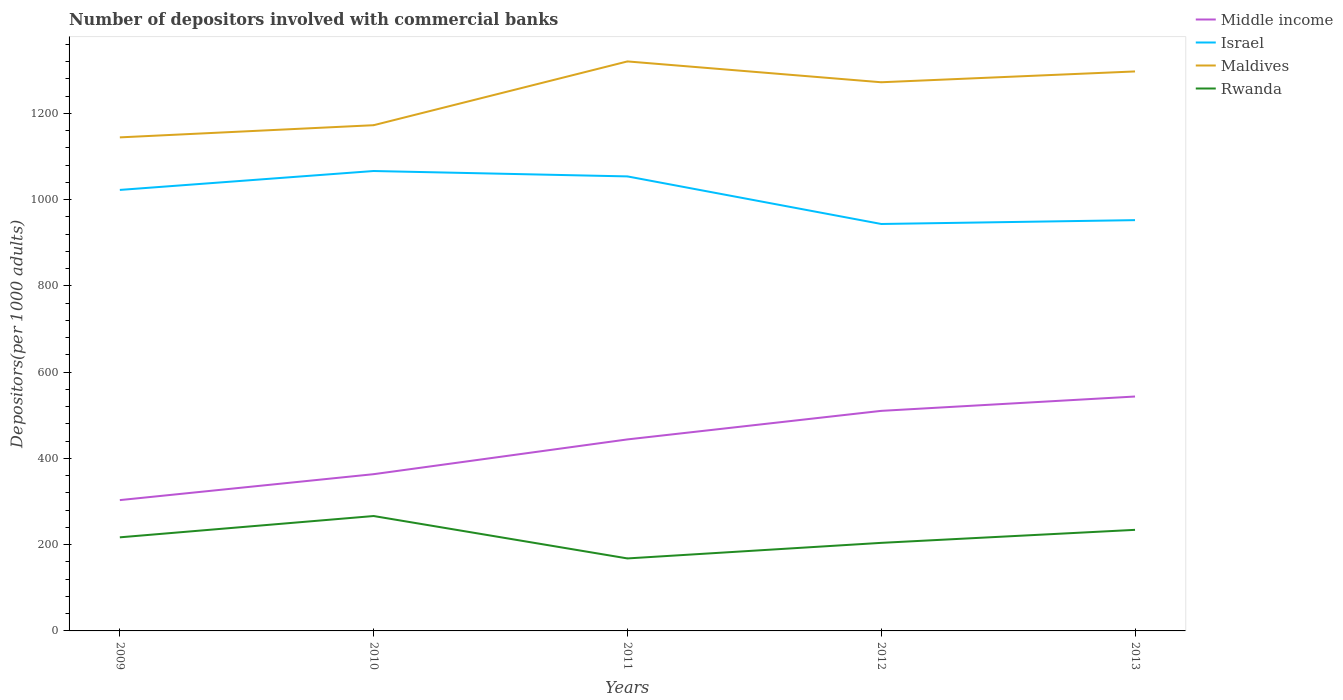How many different coloured lines are there?
Give a very brief answer. 4. Across all years, what is the maximum number of depositors involved with commercial banks in Maldives?
Your answer should be compact. 1144.57. What is the total number of depositors involved with commercial banks in Middle income in the graph?
Provide a succinct answer. -206.95. What is the difference between the highest and the second highest number of depositors involved with commercial banks in Middle income?
Your answer should be compact. 240.21. How many lines are there?
Your answer should be very brief. 4. What is the difference between two consecutive major ticks on the Y-axis?
Offer a terse response. 200. Are the values on the major ticks of Y-axis written in scientific E-notation?
Provide a short and direct response. No. Does the graph contain any zero values?
Offer a terse response. No. Where does the legend appear in the graph?
Keep it short and to the point. Top right. How many legend labels are there?
Provide a succinct answer. 4. What is the title of the graph?
Your response must be concise. Number of depositors involved with commercial banks. Does "Trinidad and Tobago" appear as one of the legend labels in the graph?
Offer a terse response. No. What is the label or title of the Y-axis?
Your answer should be very brief. Depositors(per 1000 adults). What is the Depositors(per 1000 adults) of Middle income in 2009?
Your response must be concise. 303.38. What is the Depositors(per 1000 adults) in Israel in 2009?
Give a very brief answer. 1022.7. What is the Depositors(per 1000 adults) of Maldives in 2009?
Offer a very short reply. 1144.57. What is the Depositors(per 1000 adults) in Rwanda in 2009?
Provide a succinct answer. 217.05. What is the Depositors(per 1000 adults) of Middle income in 2010?
Provide a short and direct response. 363.5. What is the Depositors(per 1000 adults) of Israel in 2010?
Keep it short and to the point. 1066.56. What is the Depositors(per 1000 adults) of Maldives in 2010?
Make the answer very short. 1172.79. What is the Depositors(per 1000 adults) of Rwanda in 2010?
Offer a terse response. 266.46. What is the Depositors(per 1000 adults) of Middle income in 2011?
Ensure brevity in your answer.  444.11. What is the Depositors(per 1000 adults) in Israel in 2011?
Offer a very short reply. 1054.06. What is the Depositors(per 1000 adults) in Maldives in 2011?
Provide a succinct answer. 1320.69. What is the Depositors(per 1000 adults) of Rwanda in 2011?
Provide a succinct answer. 168.11. What is the Depositors(per 1000 adults) of Middle income in 2012?
Provide a short and direct response. 510.34. What is the Depositors(per 1000 adults) in Israel in 2012?
Keep it short and to the point. 943.72. What is the Depositors(per 1000 adults) of Maldives in 2012?
Ensure brevity in your answer.  1272.39. What is the Depositors(per 1000 adults) of Rwanda in 2012?
Your response must be concise. 204.22. What is the Depositors(per 1000 adults) of Middle income in 2013?
Your answer should be compact. 543.59. What is the Depositors(per 1000 adults) in Israel in 2013?
Your response must be concise. 952.62. What is the Depositors(per 1000 adults) in Maldives in 2013?
Provide a succinct answer. 1297.48. What is the Depositors(per 1000 adults) in Rwanda in 2013?
Your answer should be compact. 234.42. Across all years, what is the maximum Depositors(per 1000 adults) of Middle income?
Your response must be concise. 543.59. Across all years, what is the maximum Depositors(per 1000 adults) of Israel?
Keep it short and to the point. 1066.56. Across all years, what is the maximum Depositors(per 1000 adults) in Maldives?
Your answer should be compact. 1320.69. Across all years, what is the maximum Depositors(per 1000 adults) of Rwanda?
Offer a terse response. 266.46. Across all years, what is the minimum Depositors(per 1000 adults) in Middle income?
Your answer should be compact. 303.38. Across all years, what is the minimum Depositors(per 1000 adults) in Israel?
Keep it short and to the point. 943.72. Across all years, what is the minimum Depositors(per 1000 adults) in Maldives?
Keep it short and to the point. 1144.57. Across all years, what is the minimum Depositors(per 1000 adults) in Rwanda?
Keep it short and to the point. 168.11. What is the total Depositors(per 1000 adults) of Middle income in the graph?
Offer a terse response. 2164.92. What is the total Depositors(per 1000 adults) in Israel in the graph?
Provide a short and direct response. 5039.66. What is the total Depositors(per 1000 adults) in Maldives in the graph?
Your answer should be compact. 6207.91. What is the total Depositors(per 1000 adults) of Rwanda in the graph?
Give a very brief answer. 1090.24. What is the difference between the Depositors(per 1000 adults) of Middle income in 2009 and that in 2010?
Your answer should be very brief. -60.11. What is the difference between the Depositors(per 1000 adults) of Israel in 2009 and that in 2010?
Your answer should be compact. -43.86. What is the difference between the Depositors(per 1000 adults) of Maldives in 2009 and that in 2010?
Make the answer very short. -28.22. What is the difference between the Depositors(per 1000 adults) of Rwanda in 2009 and that in 2010?
Your response must be concise. -49.41. What is the difference between the Depositors(per 1000 adults) in Middle income in 2009 and that in 2011?
Your response must be concise. -140.73. What is the difference between the Depositors(per 1000 adults) of Israel in 2009 and that in 2011?
Your answer should be very brief. -31.36. What is the difference between the Depositors(per 1000 adults) in Maldives in 2009 and that in 2011?
Offer a terse response. -176.13. What is the difference between the Depositors(per 1000 adults) of Rwanda in 2009 and that in 2011?
Ensure brevity in your answer.  48.94. What is the difference between the Depositors(per 1000 adults) of Middle income in 2009 and that in 2012?
Provide a short and direct response. -206.95. What is the difference between the Depositors(per 1000 adults) of Israel in 2009 and that in 2012?
Your response must be concise. 78.98. What is the difference between the Depositors(per 1000 adults) of Maldives in 2009 and that in 2012?
Make the answer very short. -127.82. What is the difference between the Depositors(per 1000 adults) of Rwanda in 2009 and that in 2012?
Provide a short and direct response. 12.83. What is the difference between the Depositors(per 1000 adults) of Middle income in 2009 and that in 2013?
Your answer should be compact. -240.21. What is the difference between the Depositors(per 1000 adults) of Israel in 2009 and that in 2013?
Your response must be concise. 70.08. What is the difference between the Depositors(per 1000 adults) in Maldives in 2009 and that in 2013?
Ensure brevity in your answer.  -152.92. What is the difference between the Depositors(per 1000 adults) of Rwanda in 2009 and that in 2013?
Make the answer very short. -17.37. What is the difference between the Depositors(per 1000 adults) of Middle income in 2010 and that in 2011?
Give a very brief answer. -80.61. What is the difference between the Depositors(per 1000 adults) in Israel in 2010 and that in 2011?
Your response must be concise. 12.5. What is the difference between the Depositors(per 1000 adults) of Maldives in 2010 and that in 2011?
Offer a very short reply. -147.91. What is the difference between the Depositors(per 1000 adults) of Rwanda in 2010 and that in 2011?
Make the answer very short. 98.35. What is the difference between the Depositors(per 1000 adults) in Middle income in 2010 and that in 2012?
Make the answer very short. -146.84. What is the difference between the Depositors(per 1000 adults) in Israel in 2010 and that in 2012?
Keep it short and to the point. 122.84. What is the difference between the Depositors(per 1000 adults) of Maldives in 2010 and that in 2012?
Make the answer very short. -99.6. What is the difference between the Depositors(per 1000 adults) of Rwanda in 2010 and that in 2012?
Give a very brief answer. 62.24. What is the difference between the Depositors(per 1000 adults) of Middle income in 2010 and that in 2013?
Ensure brevity in your answer.  -180.09. What is the difference between the Depositors(per 1000 adults) in Israel in 2010 and that in 2013?
Offer a terse response. 113.94. What is the difference between the Depositors(per 1000 adults) of Maldives in 2010 and that in 2013?
Your answer should be compact. -124.7. What is the difference between the Depositors(per 1000 adults) in Rwanda in 2010 and that in 2013?
Your answer should be compact. 32.04. What is the difference between the Depositors(per 1000 adults) of Middle income in 2011 and that in 2012?
Your answer should be compact. -66.23. What is the difference between the Depositors(per 1000 adults) of Israel in 2011 and that in 2012?
Offer a very short reply. 110.33. What is the difference between the Depositors(per 1000 adults) of Maldives in 2011 and that in 2012?
Ensure brevity in your answer.  48.3. What is the difference between the Depositors(per 1000 adults) in Rwanda in 2011 and that in 2012?
Ensure brevity in your answer.  -36.1. What is the difference between the Depositors(per 1000 adults) in Middle income in 2011 and that in 2013?
Offer a very short reply. -99.48. What is the difference between the Depositors(per 1000 adults) in Israel in 2011 and that in 2013?
Your answer should be compact. 101.44. What is the difference between the Depositors(per 1000 adults) in Maldives in 2011 and that in 2013?
Ensure brevity in your answer.  23.21. What is the difference between the Depositors(per 1000 adults) of Rwanda in 2011 and that in 2013?
Provide a succinct answer. -66.31. What is the difference between the Depositors(per 1000 adults) of Middle income in 2012 and that in 2013?
Keep it short and to the point. -33.25. What is the difference between the Depositors(per 1000 adults) in Israel in 2012 and that in 2013?
Offer a terse response. -8.9. What is the difference between the Depositors(per 1000 adults) of Maldives in 2012 and that in 2013?
Offer a terse response. -25.1. What is the difference between the Depositors(per 1000 adults) of Rwanda in 2012 and that in 2013?
Give a very brief answer. -30.2. What is the difference between the Depositors(per 1000 adults) in Middle income in 2009 and the Depositors(per 1000 adults) in Israel in 2010?
Offer a very short reply. -763.18. What is the difference between the Depositors(per 1000 adults) in Middle income in 2009 and the Depositors(per 1000 adults) in Maldives in 2010?
Your response must be concise. -869.4. What is the difference between the Depositors(per 1000 adults) in Middle income in 2009 and the Depositors(per 1000 adults) in Rwanda in 2010?
Give a very brief answer. 36.93. What is the difference between the Depositors(per 1000 adults) in Israel in 2009 and the Depositors(per 1000 adults) in Maldives in 2010?
Your response must be concise. -150.09. What is the difference between the Depositors(per 1000 adults) in Israel in 2009 and the Depositors(per 1000 adults) in Rwanda in 2010?
Keep it short and to the point. 756.24. What is the difference between the Depositors(per 1000 adults) in Maldives in 2009 and the Depositors(per 1000 adults) in Rwanda in 2010?
Keep it short and to the point. 878.11. What is the difference between the Depositors(per 1000 adults) of Middle income in 2009 and the Depositors(per 1000 adults) of Israel in 2011?
Give a very brief answer. -750.67. What is the difference between the Depositors(per 1000 adults) in Middle income in 2009 and the Depositors(per 1000 adults) in Maldives in 2011?
Your response must be concise. -1017.31. What is the difference between the Depositors(per 1000 adults) in Middle income in 2009 and the Depositors(per 1000 adults) in Rwanda in 2011?
Your response must be concise. 135.27. What is the difference between the Depositors(per 1000 adults) in Israel in 2009 and the Depositors(per 1000 adults) in Maldives in 2011?
Make the answer very short. -297.99. What is the difference between the Depositors(per 1000 adults) in Israel in 2009 and the Depositors(per 1000 adults) in Rwanda in 2011?
Make the answer very short. 854.59. What is the difference between the Depositors(per 1000 adults) in Maldives in 2009 and the Depositors(per 1000 adults) in Rwanda in 2011?
Your answer should be compact. 976.45. What is the difference between the Depositors(per 1000 adults) of Middle income in 2009 and the Depositors(per 1000 adults) of Israel in 2012?
Make the answer very short. -640.34. What is the difference between the Depositors(per 1000 adults) in Middle income in 2009 and the Depositors(per 1000 adults) in Maldives in 2012?
Offer a very short reply. -969. What is the difference between the Depositors(per 1000 adults) of Middle income in 2009 and the Depositors(per 1000 adults) of Rwanda in 2012?
Your response must be concise. 99.17. What is the difference between the Depositors(per 1000 adults) of Israel in 2009 and the Depositors(per 1000 adults) of Maldives in 2012?
Offer a terse response. -249.69. What is the difference between the Depositors(per 1000 adults) of Israel in 2009 and the Depositors(per 1000 adults) of Rwanda in 2012?
Give a very brief answer. 818.48. What is the difference between the Depositors(per 1000 adults) in Maldives in 2009 and the Depositors(per 1000 adults) in Rwanda in 2012?
Your answer should be very brief. 940.35. What is the difference between the Depositors(per 1000 adults) of Middle income in 2009 and the Depositors(per 1000 adults) of Israel in 2013?
Offer a very short reply. -649.24. What is the difference between the Depositors(per 1000 adults) in Middle income in 2009 and the Depositors(per 1000 adults) in Maldives in 2013?
Ensure brevity in your answer.  -994.1. What is the difference between the Depositors(per 1000 adults) in Middle income in 2009 and the Depositors(per 1000 adults) in Rwanda in 2013?
Your answer should be compact. 68.97. What is the difference between the Depositors(per 1000 adults) of Israel in 2009 and the Depositors(per 1000 adults) of Maldives in 2013?
Your answer should be very brief. -274.78. What is the difference between the Depositors(per 1000 adults) of Israel in 2009 and the Depositors(per 1000 adults) of Rwanda in 2013?
Your answer should be compact. 788.28. What is the difference between the Depositors(per 1000 adults) of Maldives in 2009 and the Depositors(per 1000 adults) of Rwanda in 2013?
Ensure brevity in your answer.  910.15. What is the difference between the Depositors(per 1000 adults) in Middle income in 2010 and the Depositors(per 1000 adults) in Israel in 2011?
Ensure brevity in your answer.  -690.56. What is the difference between the Depositors(per 1000 adults) of Middle income in 2010 and the Depositors(per 1000 adults) of Maldives in 2011?
Offer a terse response. -957.2. What is the difference between the Depositors(per 1000 adults) of Middle income in 2010 and the Depositors(per 1000 adults) of Rwanda in 2011?
Provide a succinct answer. 195.39. What is the difference between the Depositors(per 1000 adults) in Israel in 2010 and the Depositors(per 1000 adults) in Maldives in 2011?
Your answer should be very brief. -254.13. What is the difference between the Depositors(per 1000 adults) of Israel in 2010 and the Depositors(per 1000 adults) of Rwanda in 2011?
Offer a very short reply. 898.45. What is the difference between the Depositors(per 1000 adults) of Maldives in 2010 and the Depositors(per 1000 adults) of Rwanda in 2011?
Keep it short and to the point. 1004.68. What is the difference between the Depositors(per 1000 adults) in Middle income in 2010 and the Depositors(per 1000 adults) in Israel in 2012?
Your response must be concise. -580.23. What is the difference between the Depositors(per 1000 adults) in Middle income in 2010 and the Depositors(per 1000 adults) in Maldives in 2012?
Keep it short and to the point. -908.89. What is the difference between the Depositors(per 1000 adults) of Middle income in 2010 and the Depositors(per 1000 adults) of Rwanda in 2012?
Your answer should be very brief. 159.28. What is the difference between the Depositors(per 1000 adults) of Israel in 2010 and the Depositors(per 1000 adults) of Maldives in 2012?
Make the answer very short. -205.83. What is the difference between the Depositors(per 1000 adults) of Israel in 2010 and the Depositors(per 1000 adults) of Rwanda in 2012?
Give a very brief answer. 862.35. What is the difference between the Depositors(per 1000 adults) of Maldives in 2010 and the Depositors(per 1000 adults) of Rwanda in 2012?
Your answer should be very brief. 968.57. What is the difference between the Depositors(per 1000 adults) of Middle income in 2010 and the Depositors(per 1000 adults) of Israel in 2013?
Offer a terse response. -589.12. What is the difference between the Depositors(per 1000 adults) of Middle income in 2010 and the Depositors(per 1000 adults) of Maldives in 2013?
Your answer should be compact. -933.99. What is the difference between the Depositors(per 1000 adults) in Middle income in 2010 and the Depositors(per 1000 adults) in Rwanda in 2013?
Offer a very short reply. 129.08. What is the difference between the Depositors(per 1000 adults) of Israel in 2010 and the Depositors(per 1000 adults) of Maldives in 2013?
Your answer should be compact. -230.92. What is the difference between the Depositors(per 1000 adults) in Israel in 2010 and the Depositors(per 1000 adults) in Rwanda in 2013?
Provide a short and direct response. 832.14. What is the difference between the Depositors(per 1000 adults) in Maldives in 2010 and the Depositors(per 1000 adults) in Rwanda in 2013?
Make the answer very short. 938.37. What is the difference between the Depositors(per 1000 adults) in Middle income in 2011 and the Depositors(per 1000 adults) in Israel in 2012?
Offer a terse response. -499.61. What is the difference between the Depositors(per 1000 adults) in Middle income in 2011 and the Depositors(per 1000 adults) in Maldives in 2012?
Make the answer very short. -828.28. What is the difference between the Depositors(per 1000 adults) of Middle income in 2011 and the Depositors(per 1000 adults) of Rwanda in 2012?
Give a very brief answer. 239.89. What is the difference between the Depositors(per 1000 adults) in Israel in 2011 and the Depositors(per 1000 adults) in Maldives in 2012?
Provide a succinct answer. -218.33. What is the difference between the Depositors(per 1000 adults) of Israel in 2011 and the Depositors(per 1000 adults) of Rwanda in 2012?
Give a very brief answer. 849.84. What is the difference between the Depositors(per 1000 adults) of Maldives in 2011 and the Depositors(per 1000 adults) of Rwanda in 2012?
Provide a succinct answer. 1116.48. What is the difference between the Depositors(per 1000 adults) of Middle income in 2011 and the Depositors(per 1000 adults) of Israel in 2013?
Provide a short and direct response. -508.51. What is the difference between the Depositors(per 1000 adults) of Middle income in 2011 and the Depositors(per 1000 adults) of Maldives in 2013?
Your response must be concise. -853.37. What is the difference between the Depositors(per 1000 adults) in Middle income in 2011 and the Depositors(per 1000 adults) in Rwanda in 2013?
Your answer should be compact. 209.69. What is the difference between the Depositors(per 1000 adults) in Israel in 2011 and the Depositors(per 1000 adults) in Maldives in 2013?
Provide a short and direct response. -243.43. What is the difference between the Depositors(per 1000 adults) in Israel in 2011 and the Depositors(per 1000 adults) in Rwanda in 2013?
Keep it short and to the point. 819.64. What is the difference between the Depositors(per 1000 adults) in Maldives in 2011 and the Depositors(per 1000 adults) in Rwanda in 2013?
Your answer should be very brief. 1086.28. What is the difference between the Depositors(per 1000 adults) of Middle income in 2012 and the Depositors(per 1000 adults) of Israel in 2013?
Offer a very short reply. -442.29. What is the difference between the Depositors(per 1000 adults) of Middle income in 2012 and the Depositors(per 1000 adults) of Maldives in 2013?
Offer a very short reply. -787.15. What is the difference between the Depositors(per 1000 adults) of Middle income in 2012 and the Depositors(per 1000 adults) of Rwanda in 2013?
Give a very brief answer. 275.92. What is the difference between the Depositors(per 1000 adults) in Israel in 2012 and the Depositors(per 1000 adults) in Maldives in 2013?
Your response must be concise. -353.76. What is the difference between the Depositors(per 1000 adults) in Israel in 2012 and the Depositors(per 1000 adults) in Rwanda in 2013?
Your answer should be very brief. 709.31. What is the difference between the Depositors(per 1000 adults) in Maldives in 2012 and the Depositors(per 1000 adults) in Rwanda in 2013?
Offer a very short reply. 1037.97. What is the average Depositors(per 1000 adults) of Middle income per year?
Ensure brevity in your answer.  432.98. What is the average Depositors(per 1000 adults) of Israel per year?
Give a very brief answer. 1007.93. What is the average Depositors(per 1000 adults) of Maldives per year?
Your answer should be very brief. 1241.58. What is the average Depositors(per 1000 adults) in Rwanda per year?
Offer a very short reply. 218.05. In the year 2009, what is the difference between the Depositors(per 1000 adults) in Middle income and Depositors(per 1000 adults) in Israel?
Keep it short and to the point. -719.32. In the year 2009, what is the difference between the Depositors(per 1000 adults) in Middle income and Depositors(per 1000 adults) in Maldives?
Make the answer very short. -841.18. In the year 2009, what is the difference between the Depositors(per 1000 adults) in Middle income and Depositors(per 1000 adults) in Rwanda?
Your response must be concise. 86.34. In the year 2009, what is the difference between the Depositors(per 1000 adults) in Israel and Depositors(per 1000 adults) in Maldives?
Make the answer very short. -121.86. In the year 2009, what is the difference between the Depositors(per 1000 adults) in Israel and Depositors(per 1000 adults) in Rwanda?
Provide a short and direct response. 805.65. In the year 2009, what is the difference between the Depositors(per 1000 adults) in Maldives and Depositors(per 1000 adults) in Rwanda?
Offer a terse response. 927.52. In the year 2010, what is the difference between the Depositors(per 1000 adults) in Middle income and Depositors(per 1000 adults) in Israel?
Provide a succinct answer. -703.07. In the year 2010, what is the difference between the Depositors(per 1000 adults) of Middle income and Depositors(per 1000 adults) of Maldives?
Make the answer very short. -809.29. In the year 2010, what is the difference between the Depositors(per 1000 adults) of Middle income and Depositors(per 1000 adults) of Rwanda?
Your answer should be very brief. 97.04. In the year 2010, what is the difference between the Depositors(per 1000 adults) in Israel and Depositors(per 1000 adults) in Maldives?
Your response must be concise. -106.22. In the year 2010, what is the difference between the Depositors(per 1000 adults) of Israel and Depositors(per 1000 adults) of Rwanda?
Offer a terse response. 800.1. In the year 2010, what is the difference between the Depositors(per 1000 adults) in Maldives and Depositors(per 1000 adults) in Rwanda?
Give a very brief answer. 906.33. In the year 2011, what is the difference between the Depositors(per 1000 adults) of Middle income and Depositors(per 1000 adults) of Israel?
Ensure brevity in your answer.  -609.95. In the year 2011, what is the difference between the Depositors(per 1000 adults) of Middle income and Depositors(per 1000 adults) of Maldives?
Your answer should be very brief. -876.58. In the year 2011, what is the difference between the Depositors(per 1000 adults) of Middle income and Depositors(per 1000 adults) of Rwanda?
Provide a short and direct response. 276. In the year 2011, what is the difference between the Depositors(per 1000 adults) of Israel and Depositors(per 1000 adults) of Maldives?
Provide a short and direct response. -266.63. In the year 2011, what is the difference between the Depositors(per 1000 adults) of Israel and Depositors(per 1000 adults) of Rwanda?
Your answer should be very brief. 885.95. In the year 2011, what is the difference between the Depositors(per 1000 adults) in Maldives and Depositors(per 1000 adults) in Rwanda?
Your answer should be very brief. 1152.58. In the year 2012, what is the difference between the Depositors(per 1000 adults) of Middle income and Depositors(per 1000 adults) of Israel?
Give a very brief answer. -433.39. In the year 2012, what is the difference between the Depositors(per 1000 adults) of Middle income and Depositors(per 1000 adults) of Maldives?
Provide a succinct answer. -762.05. In the year 2012, what is the difference between the Depositors(per 1000 adults) of Middle income and Depositors(per 1000 adults) of Rwanda?
Your answer should be very brief. 306.12. In the year 2012, what is the difference between the Depositors(per 1000 adults) of Israel and Depositors(per 1000 adults) of Maldives?
Provide a short and direct response. -328.66. In the year 2012, what is the difference between the Depositors(per 1000 adults) in Israel and Depositors(per 1000 adults) in Rwanda?
Provide a short and direct response. 739.51. In the year 2012, what is the difference between the Depositors(per 1000 adults) of Maldives and Depositors(per 1000 adults) of Rwanda?
Offer a very short reply. 1068.17. In the year 2013, what is the difference between the Depositors(per 1000 adults) in Middle income and Depositors(per 1000 adults) in Israel?
Offer a very short reply. -409.03. In the year 2013, what is the difference between the Depositors(per 1000 adults) in Middle income and Depositors(per 1000 adults) in Maldives?
Your answer should be compact. -753.89. In the year 2013, what is the difference between the Depositors(per 1000 adults) in Middle income and Depositors(per 1000 adults) in Rwanda?
Ensure brevity in your answer.  309.17. In the year 2013, what is the difference between the Depositors(per 1000 adults) of Israel and Depositors(per 1000 adults) of Maldives?
Your answer should be very brief. -344.86. In the year 2013, what is the difference between the Depositors(per 1000 adults) of Israel and Depositors(per 1000 adults) of Rwanda?
Your answer should be compact. 718.2. In the year 2013, what is the difference between the Depositors(per 1000 adults) of Maldives and Depositors(per 1000 adults) of Rwanda?
Give a very brief answer. 1063.07. What is the ratio of the Depositors(per 1000 adults) of Middle income in 2009 to that in 2010?
Offer a very short reply. 0.83. What is the ratio of the Depositors(per 1000 adults) of Israel in 2009 to that in 2010?
Offer a terse response. 0.96. What is the ratio of the Depositors(per 1000 adults) of Maldives in 2009 to that in 2010?
Make the answer very short. 0.98. What is the ratio of the Depositors(per 1000 adults) of Rwanda in 2009 to that in 2010?
Offer a very short reply. 0.81. What is the ratio of the Depositors(per 1000 adults) of Middle income in 2009 to that in 2011?
Make the answer very short. 0.68. What is the ratio of the Depositors(per 1000 adults) in Israel in 2009 to that in 2011?
Keep it short and to the point. 0.97. What is the ratio of the Depositors(per 1000 adults) in Maldives in 2009 to that in 2011?
Make the answer very short. 0.87. What is the ratio of the Depositors(per 1000 adults) in Rwanda in 2009 to that in 2011?
Give a very brief answer. 1.29. What is the ratio of the Depositors(per 1000 adults) of Middle income in 2009 to that in 2012?
Offer a terse response. 0.59. What is the ratio of the Depositors(per 1000 adults) of Israel in 2009 to that in 2012?
Offer a terse response. 1.08. What is the ratio of the Depositors(per 1000 adults) in Maldives in 2009 to that in 2012?
Offer a very short reply. 0.9. What is the ratio of the Depositors(per 1000 adults) in Rwanda in 2009 to that in 2012?
Make the answer very short. 1.06. What is the ratio of the Depositors(per 1000 adults) of Middle income in 2009 to that in 2013?
Provide a succinct answer. 0.56. What is the ratio of the Depositors(per 1000 adults) in Israel in 2009 to that in 2013?
Make the answer very short. 1.07. What is the ratio of the Depositors(per 1000 adults) in Maldives in 2009 to that in 2013?
Your answer should be compact. 0.88. What is the ratio of the Depositors(per 1000 adults) in Rwanda in 2009 to that in 2013?
Keep it short and to the point. 0.93. What is the ratio of the Depositors(per 1000 adults) of Middle income in 2010 to that in 2011?
Make the answer very short. 0.82. What is the ratio of the Depositors(per 1000 adults) of Israel in 2010 to that in 2011?
Make the answer very short. 1.01. What is the ratio of the Depositors(per 1000 adults) in Maldives in 2010 to that in 2011?
Provide a succinct answer. 0.89. What is the ratio of the Depositors(per 1000 adults) in Rwanda in 2010 to that in 2011?
Ensure brevity in your answer.  1.58. What is the ratio of the Depositors(per 1000 adults) of Middle income in 2010 to that in 2012?
Your response must be concise. 0.71. What is the ratio of the Depositors(per 1000 adults) of Israel in 2010 to that in 2012?
Keep it short and to the point. 1.13. What is the ratio of the Depositors(per 1000 adults) of Maldives in 2010 to that in 2012?
Your answer should be compact. 0.92. What is the ratio of the Depositors(per 1000 adults) of Rwanda in 2010 to that in 2012?
Provide a short and direct response. 1.3. What is the ratio of the Depositors(per 1000 adults) of Middle income in 2010 to that in 2013?
Give a very brief answer. 0.67. What is the ratio of the Depositors(per 1000 adults) of Israel in 2010 to that in 2013?
Keep it short and to the point. 1.12. What is the ratio of the Depositors(per 1000 adults) in Maldives in 2010 to that in 2013?
Provide a short and direct response. 0.9. What is the ratio of the Depositors(per 1000 adults) in Rwanda in 2010 to that in 2013?
Your response must be concise. 1.14. What is the ratio of the Depositors(per 1000 adults) of Middle income in 2011 to that in 2012?
Make the answer very short. 0.87. What is the ratio of the Depositors(per 1000 adults) in Israel in 2011 to that in 2012?
Offer a terse response. 1.12. What is the ratio of the Depositors(per 1000 adults) of Maldives in 2011 to that in 2012?
Your response must be concise. 1.04. What is the ratio of the Depositors(per 1000 adults) in Rwanda in 2011 to that in 2012?
Your response must be concise. 0.82. What is the ratio of the Depositors(per 1000 adults) in Middle income in 2011 to that in 2013?
Provide a succinct answer. 0.82. What is the ratio of the Depositors(per 1000 adults) of Israel in 2011 to that in 2013?
Give a very brief answer. 1.11. What is the ratio of the Depositors(per 1000 adults) of Maldives in 2011 to that in 2013?
Your response must be concise. 1.02. What is the ratio of the Depositors(per 1000 adults) in Rwanda in 2011 to that in 2013?
Offer a terse response. 0.72. What is the ratio of the Depositors(per 1000 adults) of Middle income in 2012 to that in 2013?
Make the answer very short. 0.94. What is the ratio of the Depositors(per 1000 adults) in Maldives in 2012 to that in 2013?
Keep it short and to the point. 0.98. What is the ratio of the Depositors(per 1000 adults) of Rwanda in 2012 to that in 2013?
Your answer should be compact. 0.87. What is the difference between the highest and the second highest Depositors(per 1000 adults) in Middle income?
Your answer should be very brief. 33.25. What is the difference between the highest and the second highest Depositors(per 1000 adults) in Israel?
Provide a succinct answer. 12.5. What is the difference between the highest and the second highest Depositors(per 1000 adults) in Maldives?
Keep it short and to the point. 23.21. What is the difference between the highest and the second highest Depositors(per 1000 adults) in Rwanda?
Make the answer very short. 32.04. What is the difference between the highest and the lowest Depositors(per 1000 adults) in Middle income?
Your response must be concise. 240.21. What is the difference between the highest and the lowest Depositors(per 1000 adults) in Israel?
Give a very brief answer. 122.84. What is the difference between the highest and the lowest Depositors(per 1000 adults) of Maldives?
Your answer should be very brief. 176.13. What is the difference between the highest and the lowest Depositors(per 1000 adults) of Rwanda?
Offer a terse response. 98.35. 